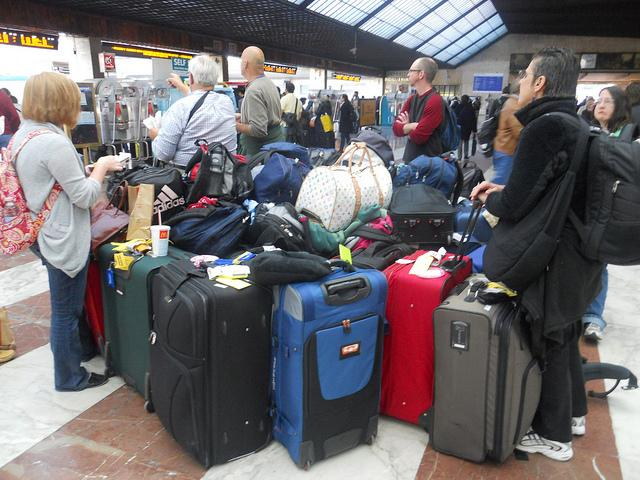What activity are these people engaged in? travel 